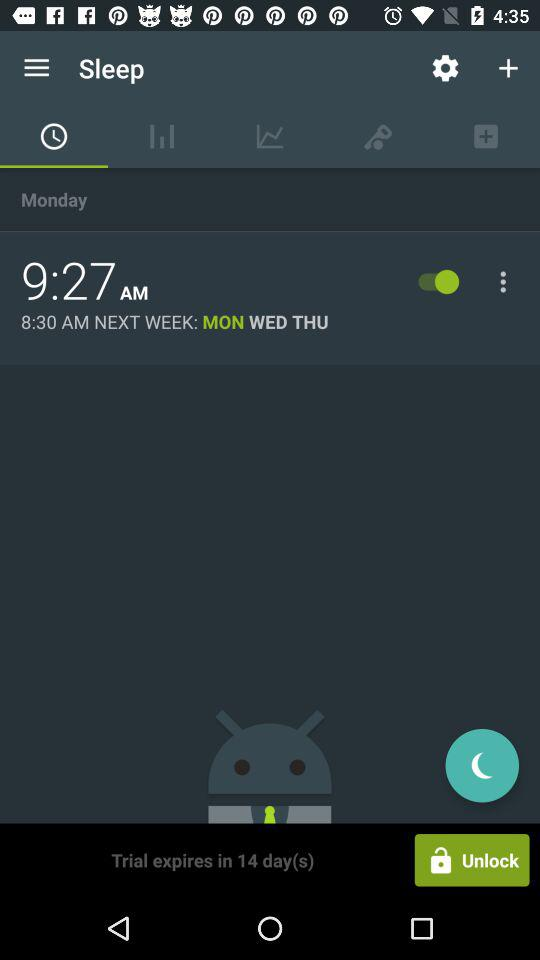For which days is the alarm set? The alarm is set for Monday, Wednesday and Thursday. 